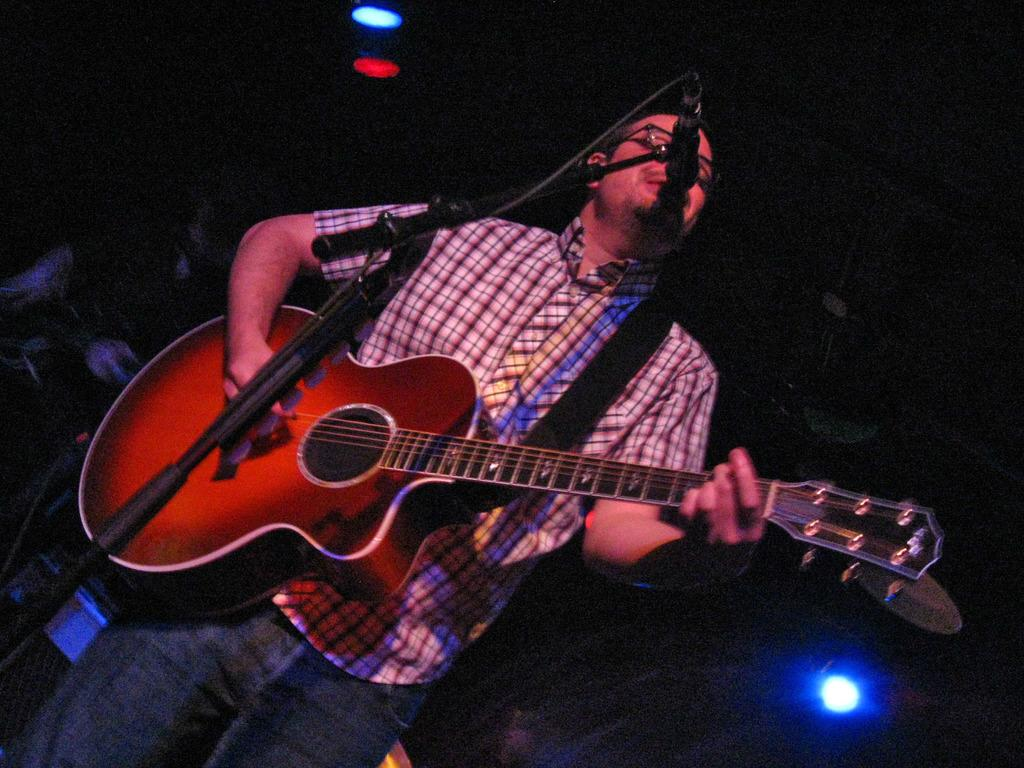What is the main subject of the image? There is a person in the image. What is the person doing in the image? The person is standing and holding a guitar in his hands. What object is in front of the person? There is a microphone in front of the person. What can be seen in the background of the image? There are flashlights in the background of the image. How would you describe the lighting in the image? The image appears to be dark. Where is the girl playing with the cannon in the image? There is no girl or cannon present in the image. What type of pest can be seen crawling on the person's guitar in the image? There are no pests visible on the guitar in the image. 